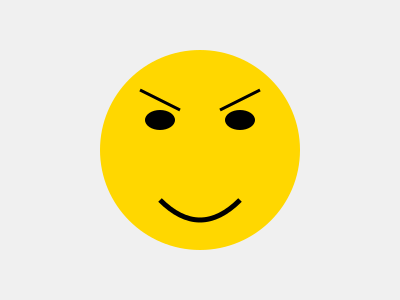In children's book illustrations, which facial feature combination most effectively conveys a sense of surprise and excitement in a character? To convey surprise and excitement in a character's facial expression, we need to consider the following key elements:

1. Eyes: Wide-open eyes are a universal indicator of surprise. In the illustration, the eyes are represented by large ellipses, emphasizing their size.

2. Eyebrows: Raised eyebrows accentuate the surprised expression. The illustration shows upward-angled lines above the eyes, representing raised eyebrows.

3. Mouth: An open mouth, often drawn in an "O" shape, signifies both surprise and excitement. The illustration depicts a curved line for the mouth, suggesting an open, smiling expression.

4. Overall face shape: A round face, as shown in the illustration, can emphasize the character's youthful and expressive nature, which is particularly important in children's book illustrations.

5. Color: The bright yellow color of the face in the illustration adds to the sense of excitement and positivity.

By combining these elements – wide eyes, raised eyebrows, and an open, smiling mouth – we create a facial expression that effectively conveys both surprise and excitement. This combination is particularly effective in children's book illustrations as it's easily recognizable and relatable for young readers.
Answer: Wide eyes, raised eyebrows, and open, smiling mouth 